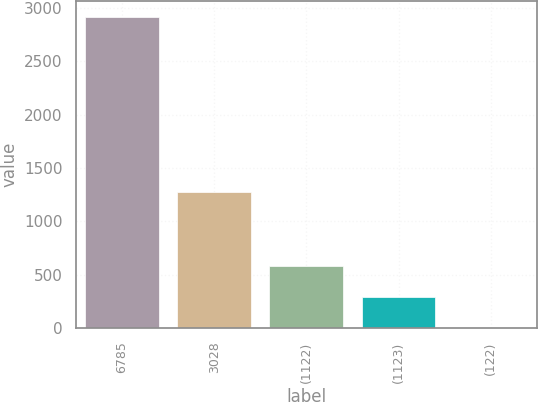Convert chart to OTSL. <chart><loc_0><loc_0><loc_500><loc_500><bar_chart><fcel>6785<fcel>3028<fcel>(1122)<fcel>(1123)<fcel>(122)<nl><fcel>2919.1<fcel>1273.6<fcel>585.14<fcel>293.39<fcel>1.64<nl></chart> 